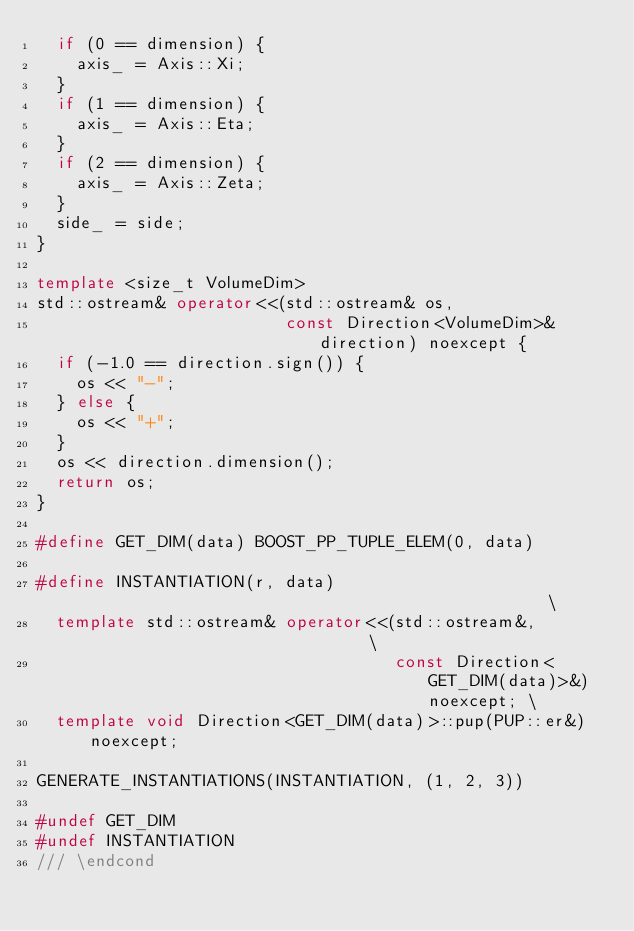Convert code to text. <code><loc_0><loc_0><loc_500><loc_500><_C++_>  if (0 == dimension) {
    axis_ = Axis::Xi;
  }
  if (1 == dimension) {
    axis_ = Axis::Eta;
  }
  if (2 == dimension) {
    axis_ = Axis::Zeta;
  }
  side_ = side;
}

template <size_t VolumeDim>
std::ostream& operator<<(std::ostream& os,
                         const Direction<VolumeDim>& direction) noexcept {
  if (-1.0 == direction.sign()) {
    os << "-";
  } else {
    os << "+";
  }
  os << direction.dimension();
  return os;
}

#define GET_DIM(data) BOOST_PP_TUPLE_ELEM(0, data)

#define INSTANTIATION(r, data)                                                 \
  template std::ostream& operator<<(std::ostream&,                             \
                                    const Direction<GET_DIM(data)>&) noexcept; \
  template void Direction<GET_DIM(data)>::pup(PUP::er&) noexcept;

GENERATE_INSTANTIATIONS(INSTANTIATION, (1, 2, 3))

#undef GET_DIM
#undef INSTANTIATION
/// \endcond
</code> 